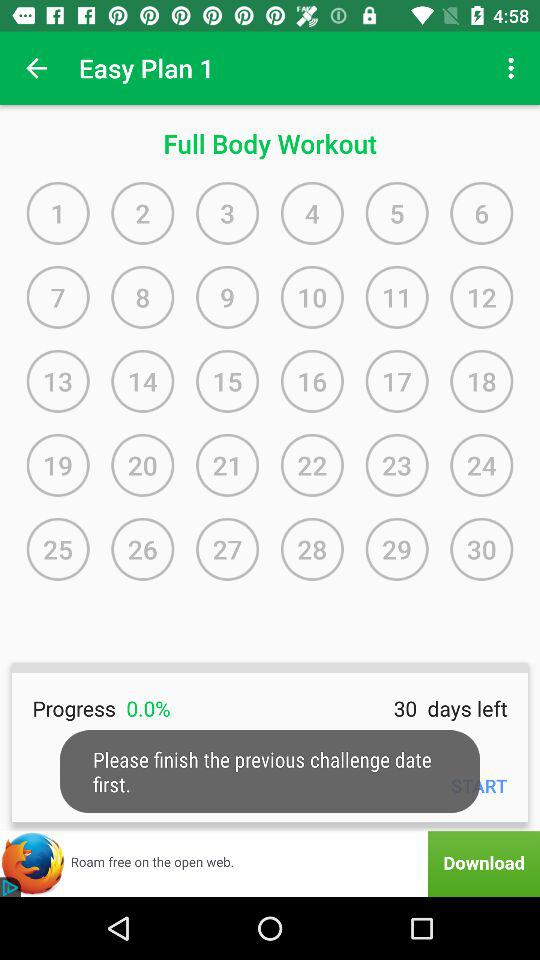What workout plan is mentioned? The mentioned workout plan is "Easy Plan 1". 